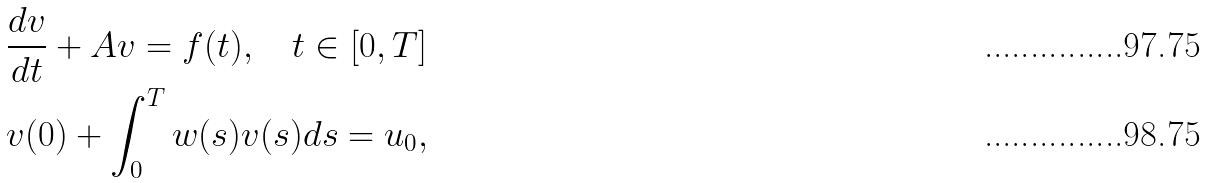<formula> <loc_0><loc_0><loc_500><loc_500>& \frac { d v } { d t } + A v = f ( t ) , \quad t \in [ 0 , T ] \\ & v ( 0 ) + \int _ { 0 } ^ { T } w ( s ) v ( s ) d s = u _ { 0 } ,</formula> 